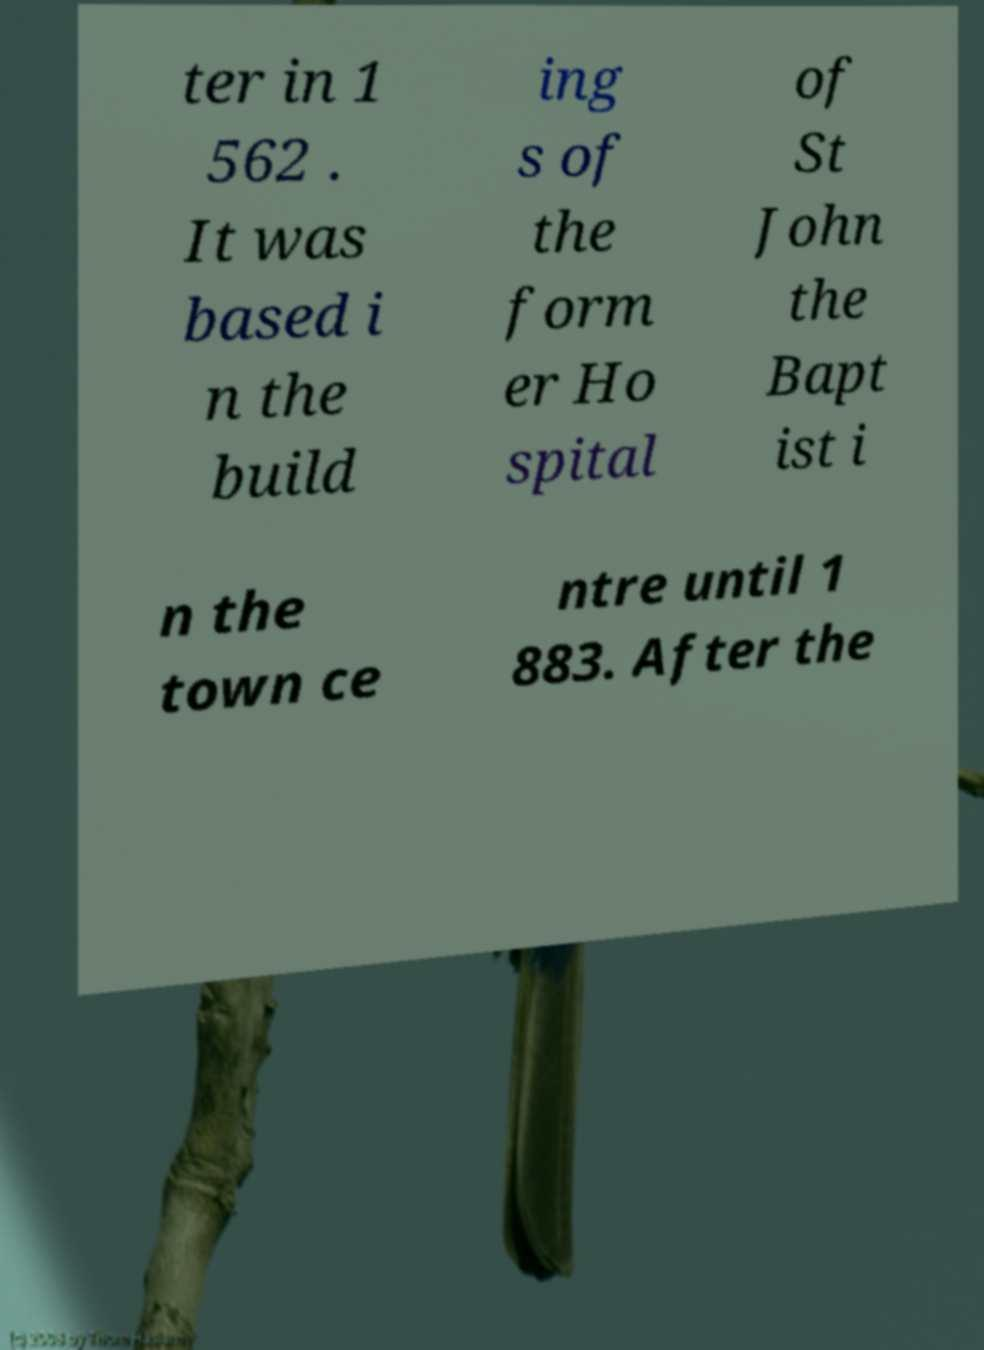Could you extract and type out the text from this image? ter in 1 562 . It was based i n the build ing s of the form er Ho spital of St John the Bapt ist i n the town ce ntre until 1 883. After the 